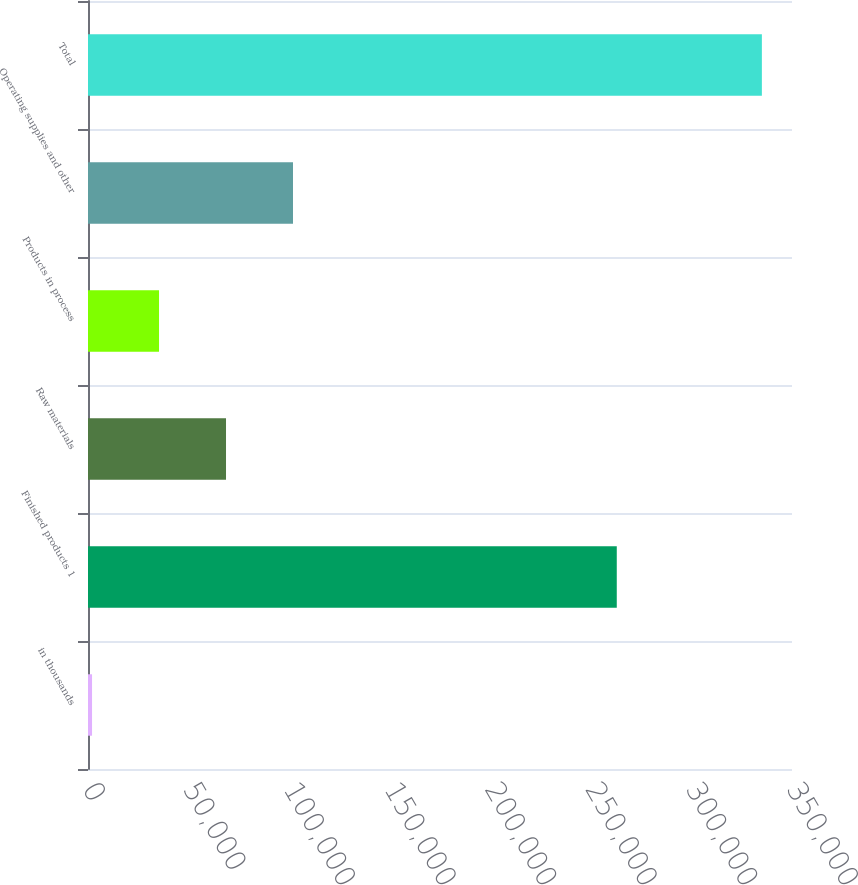Convert chart. <chart><loc_0><loc_0><loc_500><loc_500><bar_chart><fcel>in thousands<fcel>Finished products 1<fcel>Raw materials<fcel>Products in process<fcel>Operating supplies and other<fcel>Total<nl><fcel>2012<fcel>262886<fcel>68614<fcel>35313<fcel>101915<fcel>335022<nl></chart> 